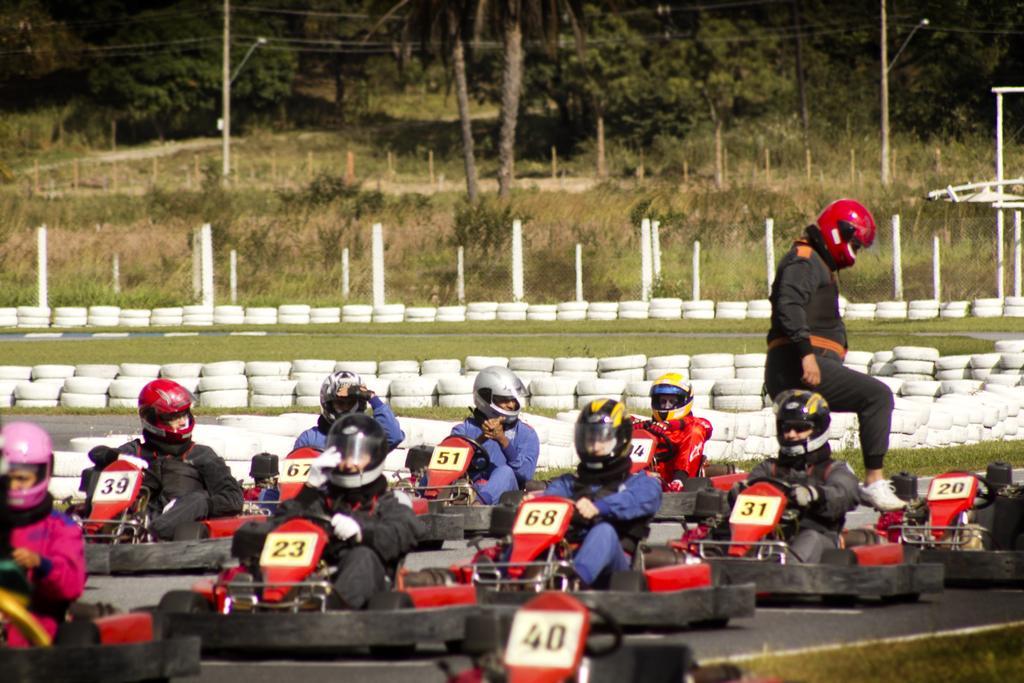Can you describe this image briefly? In this picture there are group of people sitting on the vehicles and there is a person standing. At the back there are trees and poles and there is a fence and there are tyres. At the bottom there is grass and there is a road. 